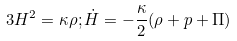<formula> <loc_0><loc_0><loc_500><loc_500>3 H ^ { 2 } = \kappa \rho ; \dot { H } = - \frac { \kappa } { 2 } ( \rho + p + \Pi )</formula> 